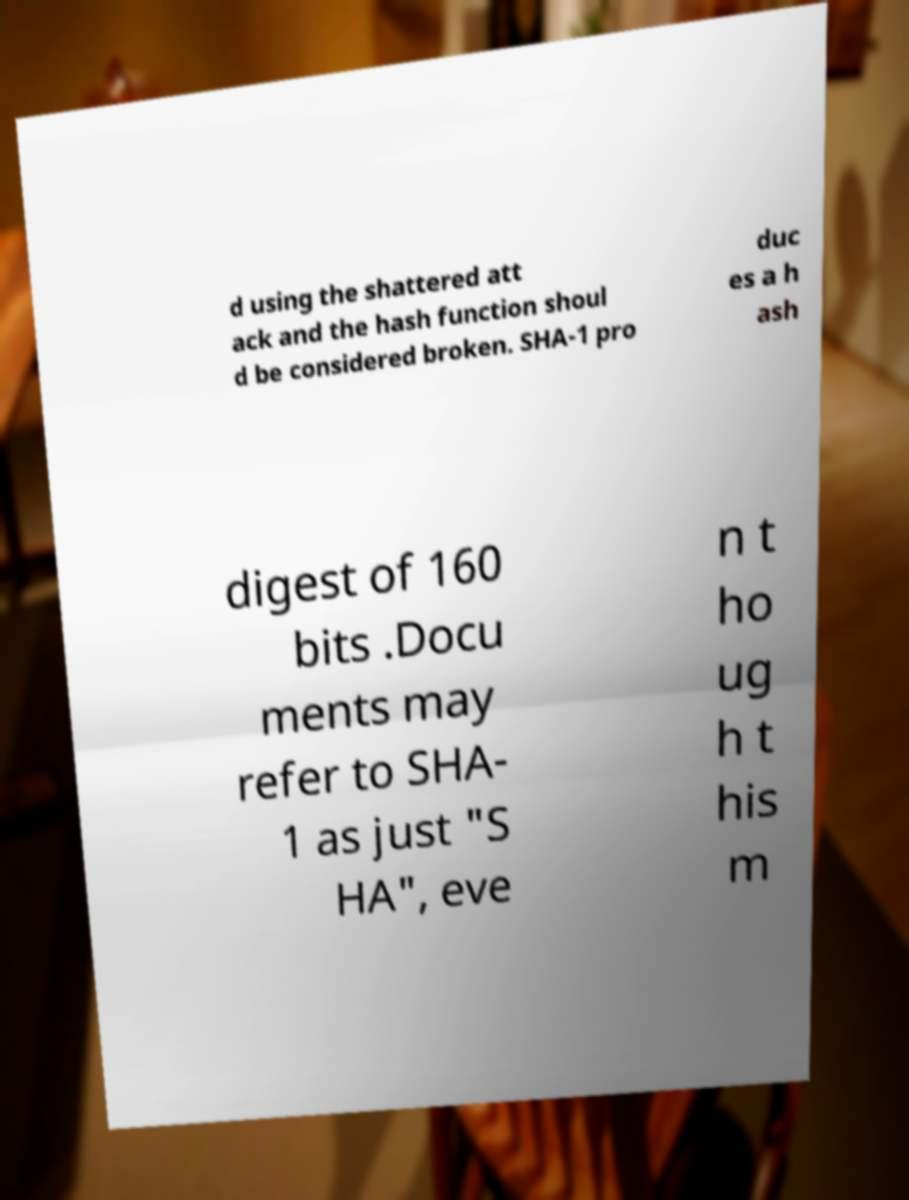Could you assist in decoding the text presented in this image and type it out clearly? d using the shattered att ack and the hash function shoul d be considered broken. SHA-1 pro duc es a h ash digest of 160 bits .Docu ments may refer to SHA- 1 as just "S HA", eve n t ho ug h t his m 